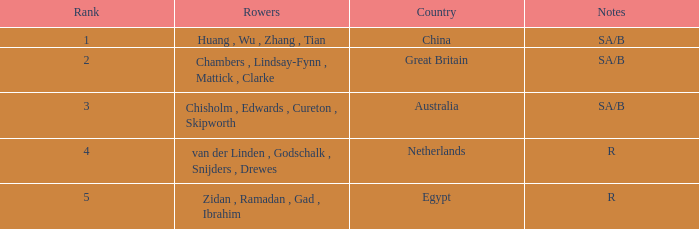What country has sa/b as the notes, and a time of 5:51.30? China. 